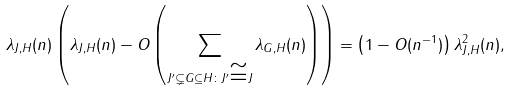Convert formula to latex. <formula><loc_0><loc_0><loc_500><loc_500>\lambda _ { J , H } ( n ) \left ( \lambda _ { J , H } ( n ) - O \left ( \sum _ { J ^ { \prime } \subsetneq G \subseteq H \colon J ^ { \prime } \cong J } \lambda _ { G , H } ( n ) \right ) \right ) = \left ( 1 - O ( n ^ { - 1 } ) \right ) \lambda ^ { 2 } _ { J , H } ( n ) ,</formula> 